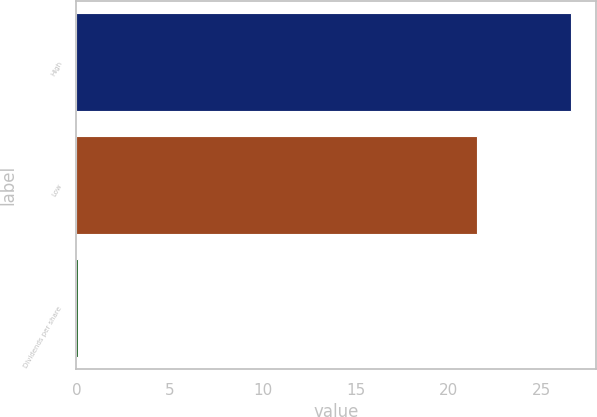<chart> <loc_0><loc_0><loc_500><loc_500><bar_chart><fcel>High<fcel>Low<fcel>Dividends per share<nl><fcel>26.6<fcel>21.54<fcel>0.08<nl></chart> 